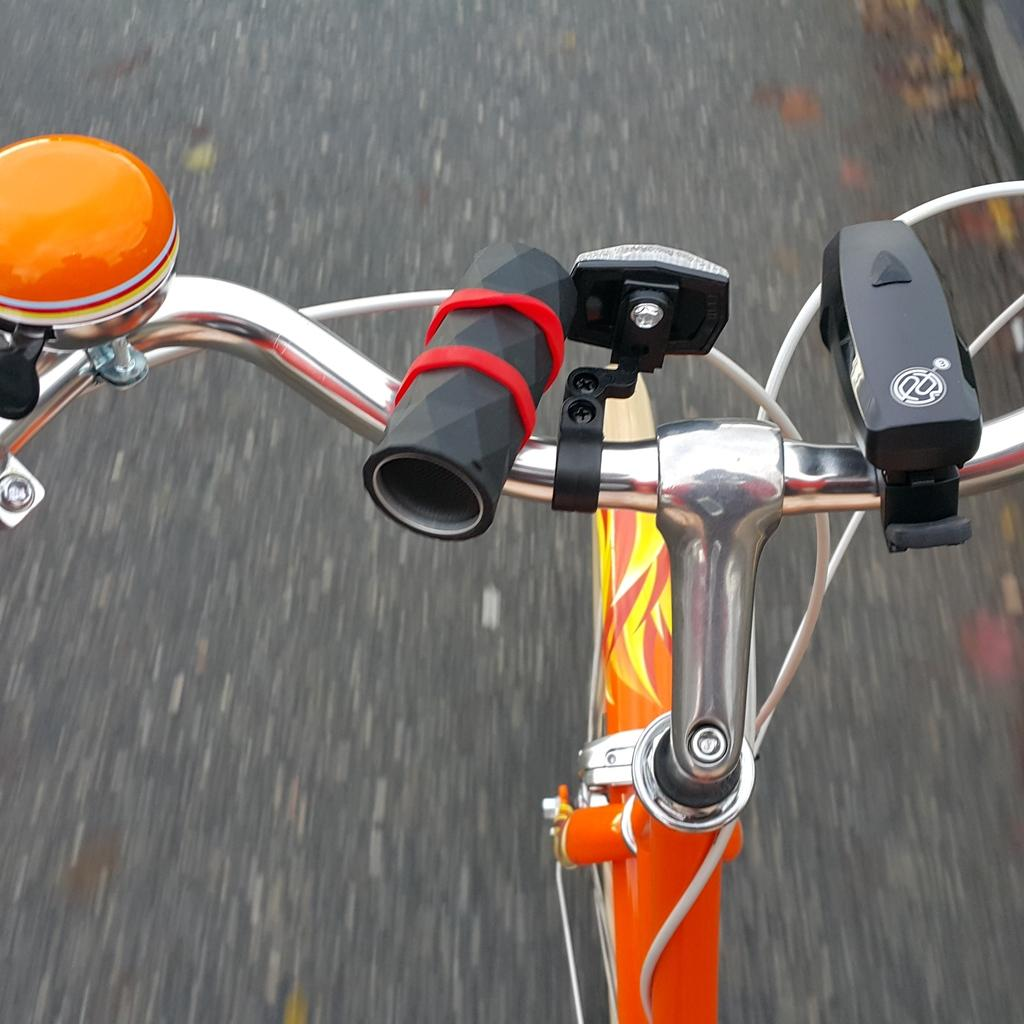What is the main subject of the image? The main subject of the image is a bicycle. Where is the bicycle located in the image? The bicycle is on the road. Is the person riding the bicycle taking a bath while riding it in the image? There is no person riding the bicycle in the image, and therefore no indication of them taking a bath. Is there a swing present in the image? There is no swing present in the image. 